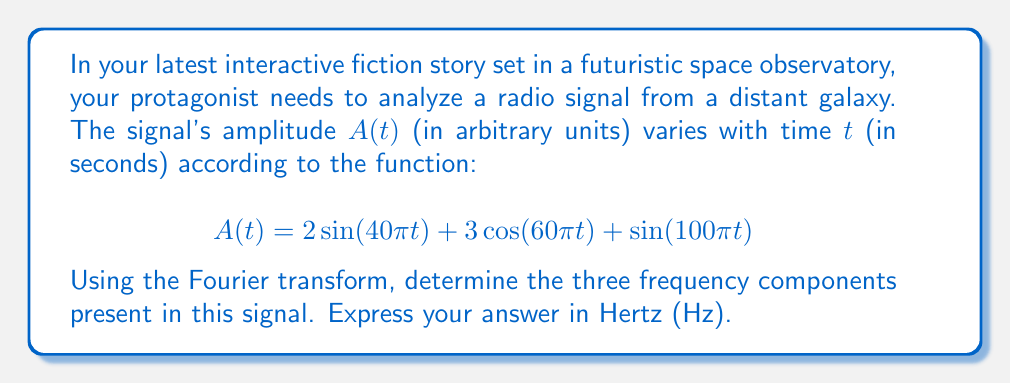Could you help me with this problem? To solve this problem, we need to understand that the Fourier transform decomposes a signal into its constituent frequency components. In this case, our signal is already expressed as a sum of sinusoidal functions, which makes our task easier.

Let's break down the given function:

1. $2\sin(40\pi t)$
2. $3\cos(60\pi t)$
3. $\sin(100\pi t)$

For each term, we need to identify the frequency. The general forms are:

- $\sin(2\pi ft)$ or $\cos(2\pi ft)$, where $f$ is the frequency in Hz.

So, for each term:

1. $2\sin(40\pi t)$
   $40\pi = 2\pi f$
   $f = 20$ Hz

2. $3\cos(60\pi t)$
   $60\pi = 2\pi f$
   $f = 30$ Hz

3. $\sin(100\pi t)$
   $100\pi = 2\pi f$
   $f = 50$ Hz

Therefore, the signal contains three frequency components: 20 Hz, 30 Hz, and 50 Hz.

Note: The amplitudes (2, 3, and 1) don't affect the frequency values but would determine the strength of each component in a frequency spectrum plot.
Answer: The three frequency components are 20 Hz, 30 Hz, and 50 Hz. 